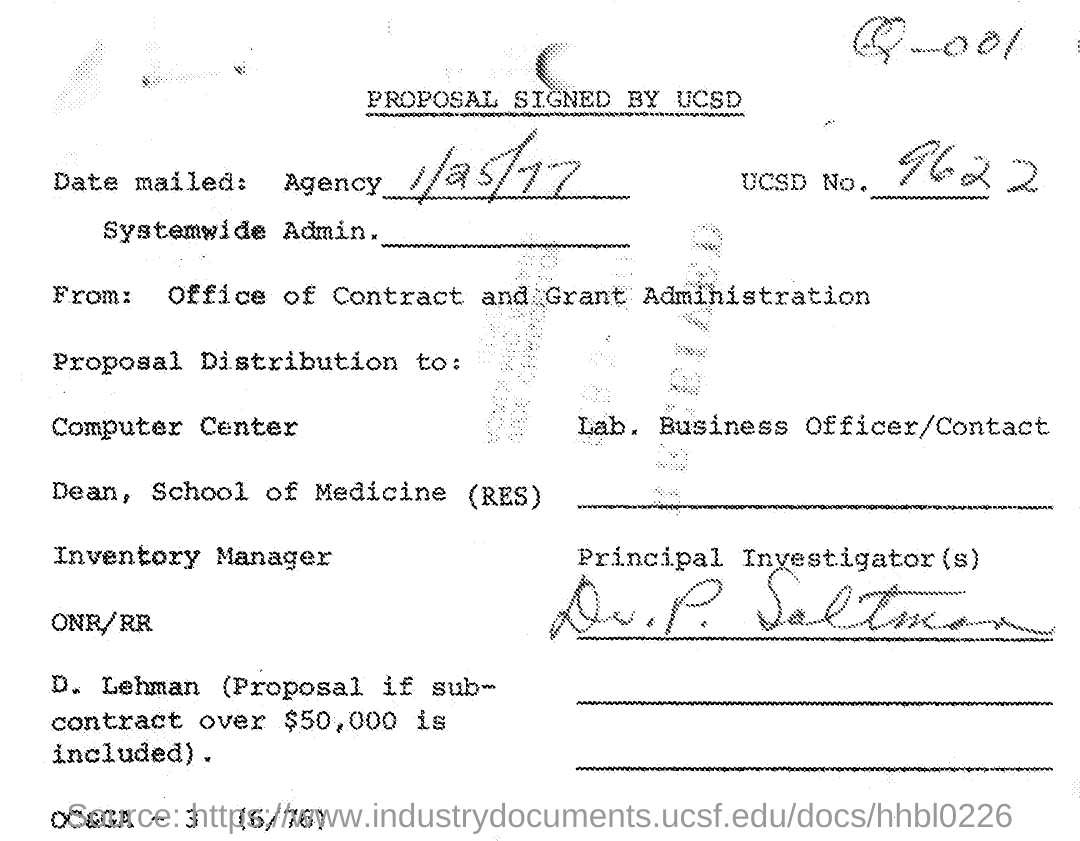Indicate a few pertinent items in this graphic. The letter was mailed on January 25, 1977. 